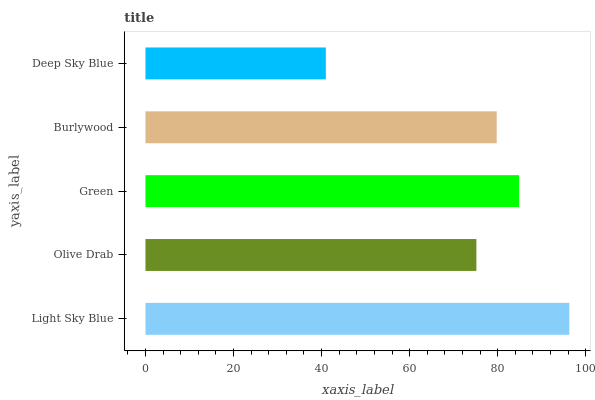Is Deep Sky Blue the minimum?
Answer yes or no. Yes. Is Light Sky Blue the maximum?
Answer yes or no. Yes. Is Olive Drab the minimum?
Answer yes or no. No. Is Olive Drab the maximum?
Answer yes or no. No. Is Light Sky Blue greater than Olive Drab?
Answer yes or no. Yes. Is Olive Drab less than Light Sky Blue?
Answer yes or no. Yes. Is Olive Drab greater than Light Sky Blue?
Answer yes or no. No. Is Light Sky Blue less than Olive Drab?
Answer yes or no. No. Is Burlywood the high median?
Answer yes or no. Yes. Is Burlywood the low median?
Answer yes or no. Yes. Is Light Sky Blue the high median?
Answer yes or no. No. Is Deep Sky Blue the low median?
Answer yes or no. No. 